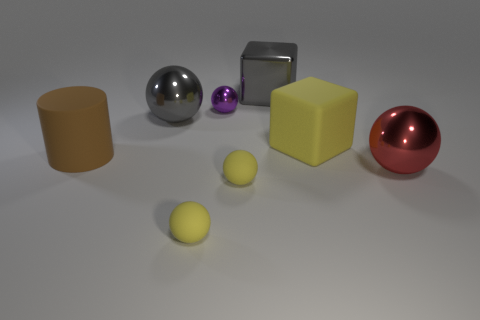How many yellow balls must be subtracted to get 1 yellow balls? 1 Subtract all purple spheres. How many spheres are left? 4 Subtract all gray spheres. How many spheres are left? 4 Subtract all green balls. Subtract all green cylinders. How many balls are left? 5 Add 2 gray metallic cylinders. How many objects exist? 10 Subtract all balls. How many objects are left? 3 Subtract 0 cyan cylinders. How many objects are left? 8 Subtract all cylinders. Subtract all purple metal spheres. How many objects are left? 6 Add 5 red metal balls. How many red metal balls are left? 6 Add 7 big yellow matte cubes. How many big yellow matte cubes exist? 8 